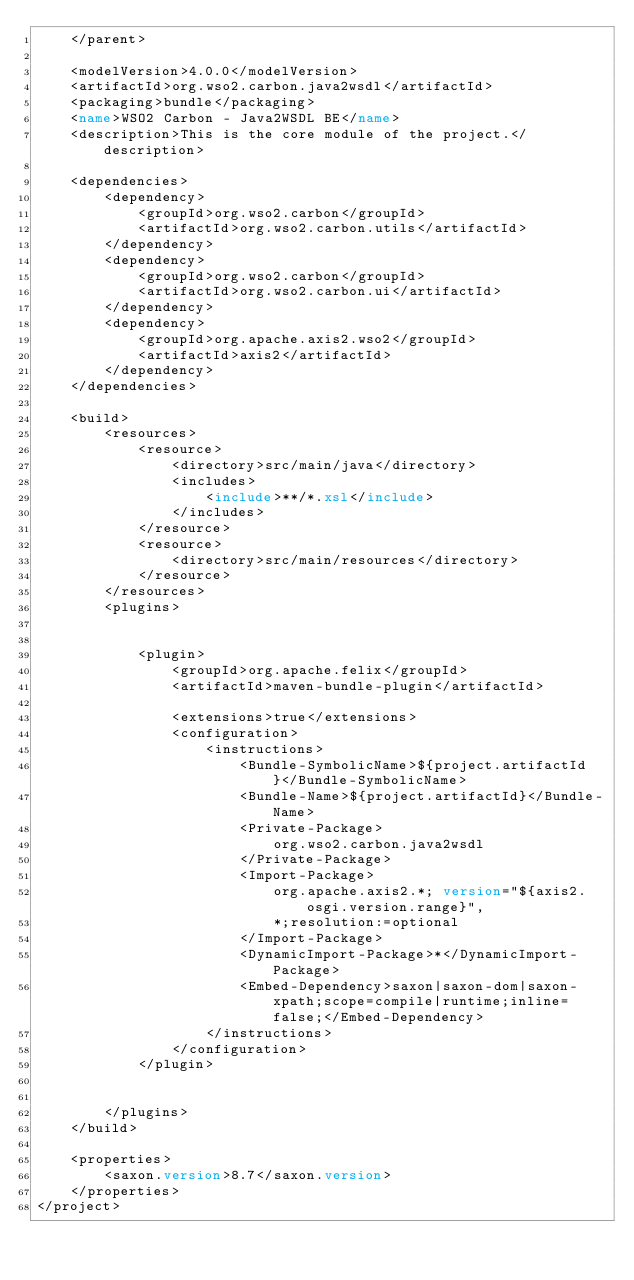<code> <loc_0><loc_0><loc_500><loc_500><_XML_>    </parent>

    <modelVersion>4.0.0</modelVersion>
    <artifactId>org.wso2.carbon.java2wsdl</artifactId>
    <packaging>bundle</packaging>
    <name>WSO2 Carbon - Java2WSDL BE</name>
    <description>This is the core module of the project.</description>

    <dependencies>
        <dependency>
            <groupId>org.wso2.carbon</groupId>
            <artifactId>org.wso2.carbon.utils</artifactId>
        </dependency>
        <dependency>
            <groupId>org.wso2.carbon</groupId>
            <artifactId>org.wso2.carbon.ui</artifactId>
        </dependency>
        <dependency>
            <groupId>org.apache.axis2.wso2</groupId>
            <artifactId>axis2</artifactId>
        </dependency>
    </dependencies>

    <build>
        <resources>
            <resource>
                <directory>src/main/java</directory>
                <includes>
                    <include>**/*.xsl</include>
                </includes>
            </resource>
            <resource>
                <directory>src/main/resources</directory>
            </resource>
        </resources>
        <plugins>
            

            <plugin>
                <groupId>org.apache.felix</groupId>
                <artifactId>maven-bundle-plugin</artifactId>
                
                <extensions>true</extensions>
                <configuration>
                    <instructions>
                        <Bundle-SymbolicName>${project.artifactId}</Bundle-SymbolicName>
                        <Bundle-Name>${project.artifactId}</Bundle-Name>
                        <Private-Package>
                            org.wso2.carbon.java2wsdl
                        </Private-Package>
                        <Import-Package>
                            org.apache.axis2.*; version="${axis2.osgi.version.range}",
                            *;resolution:=optional
                        </Import-Package>
                        <DynamicImport-Package>*</DynamicImport-Package>
                        <Embed-Dependency>saxon|saxon-dom|saxon-xpath;scope=compile|runtime;inline=false;</Embed-Dependency>
                    </instructions>
                </configuration>
            </plugin>


        </plugins>
    </build>

    <properties>
        <saxon.version>8.7</saxon.version>
    </properties>
</project>
</code> 